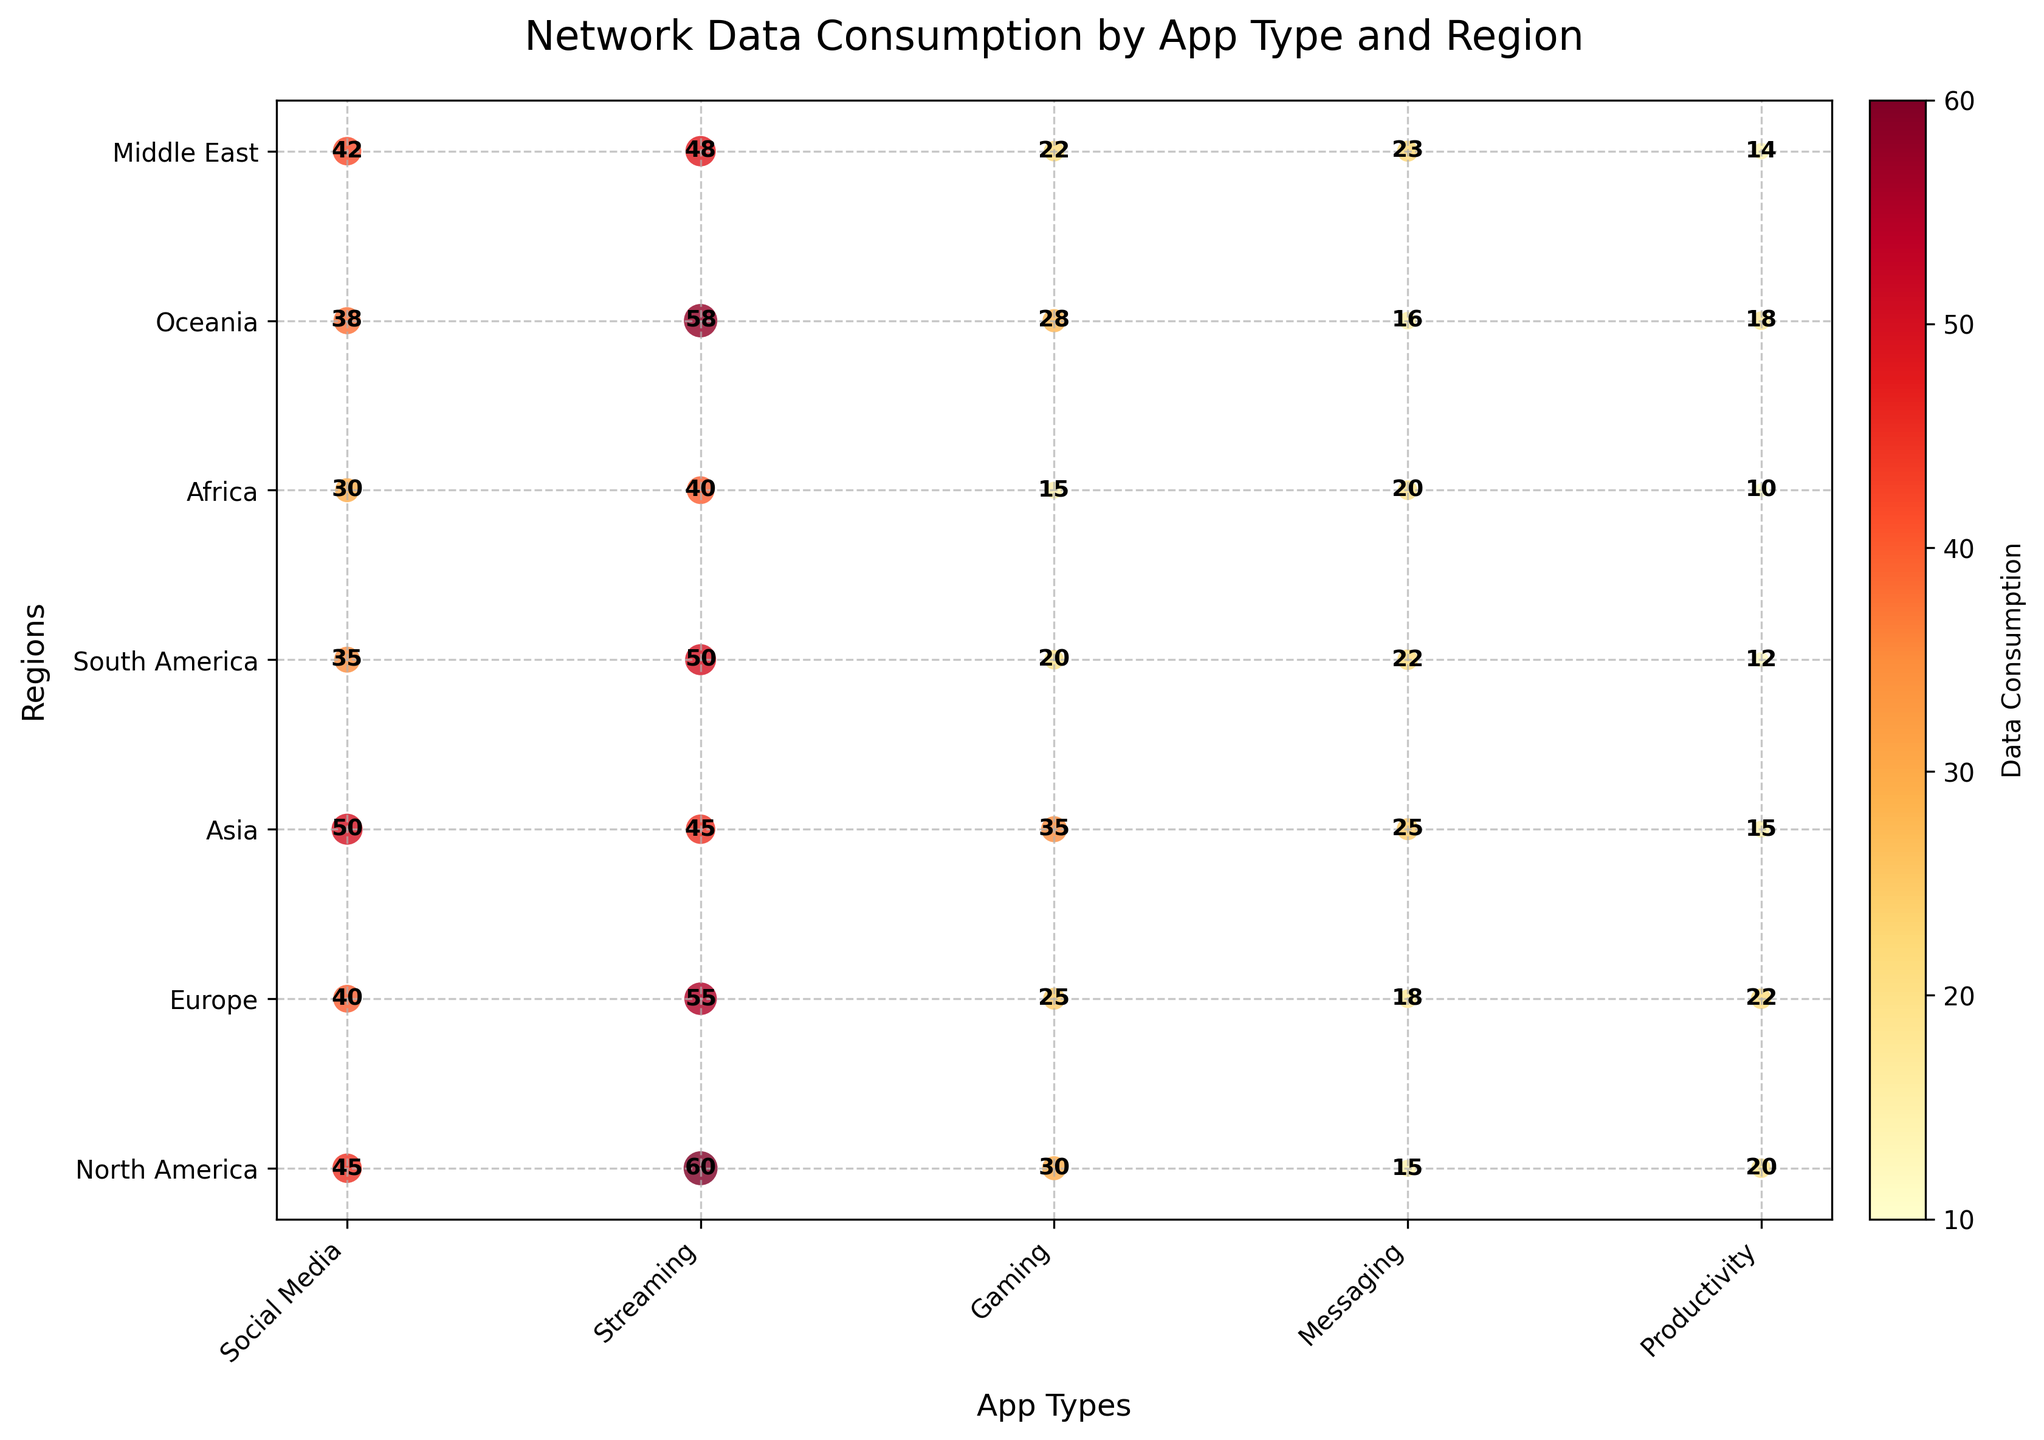What is the title of the plot? The title of the plot is usually located at the top and gives an overall description of the chart. In this case, it is visible at the top in bold.
Answer: Network Data Consumption by App Type and Region Which region has the highest network data consumption for gaming apps? Look for the largest scatter circle in the 'Gaming' column and note the corresponding region on the y-axis.
Answer: Asia How many app types are displayed in the plot? Count the number of x-axis labels that represent different app types.
Answer: 5 Which app type has the lowest average data consumption across all regions? Calculate the average consumption for each app type by summing up the values across all regions and dividing by the number of regions. Find the app type with the smallest average value.
Answer: Productivity What is the total data consumption for the Oceania region across all app types? Sum the values of data consumption for the Oceania region across all app types: (38 + 58 + 28 + 16 + 18).
Answer: 158 Which two regions have the closest data consumption values for messaging apps? Compare the data consumption values in the 'Messaging' column for all regions and identify the two regions with the smallest difference.
Answer: South America and Middle East Compare the data consumption of streaming apps between North America and Europe. Which one is higher? Look at the values of streaming data consumption for both North America and Europe, and identify which is larger.
Answer: North America What is the average data consumption for social media apps across all regions? Calculate the average by summing the data consumption values for social media apps from all regions and dividing by the number of regions: (45 + 40 + 50 + 35 + 30 + 38 + 42) / 7.
Answer: 40 For each region, which app type has the highest data consumption? Determine the app type with the highest circle size value for each region, by assessing each row of data's largest value.
Answer: - North America: Streaming 
- Europe: Streaming 
- Asia: Social Media 
- South America: Streaming 
- Africa: Streaming 
- Oceania: Streaming 
- Middle East: Social Media Which region has the most similar overall data consumption pattern to North America? Compare the data consumption values of each app type in North America to those of other regions and identify the region with the least deviation across all app types.
Answer: Oceania 